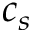<formula> <loc_0><loc_0><loc_500><loc_500>c _ { s }</formula> 